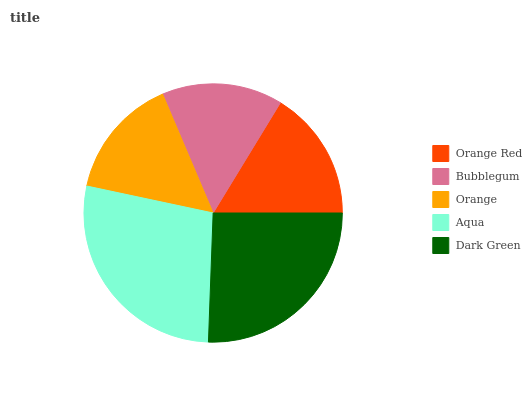Is Bubblegum the minimum?
Answer yes or no. Yes. Is Aqua the maximum?
Answer yes or no. Yes. Is Orange the minimum?
Answer yes or no. No. Is Orange the maximum?
Answer yes or no. No. Is Orange greater than Bubblegum?
Answer yes or no. Yes. Is Bubblegum less than Orange?
Answer yes or no. Yes. Is Bubblegum greater than Orange?
Answer yes or no. No. Is Orange less than Bubblegum?
Answer yes or no. No. Is Orange Red the high median?
Answer yes or no. Yes. Is Orange Red the low median?
Answer yes or no. Yes. Is Bubblegum the high median?
Answer yes or no. No. Is Bubblegum the low median?
Answer yes or no. No. 